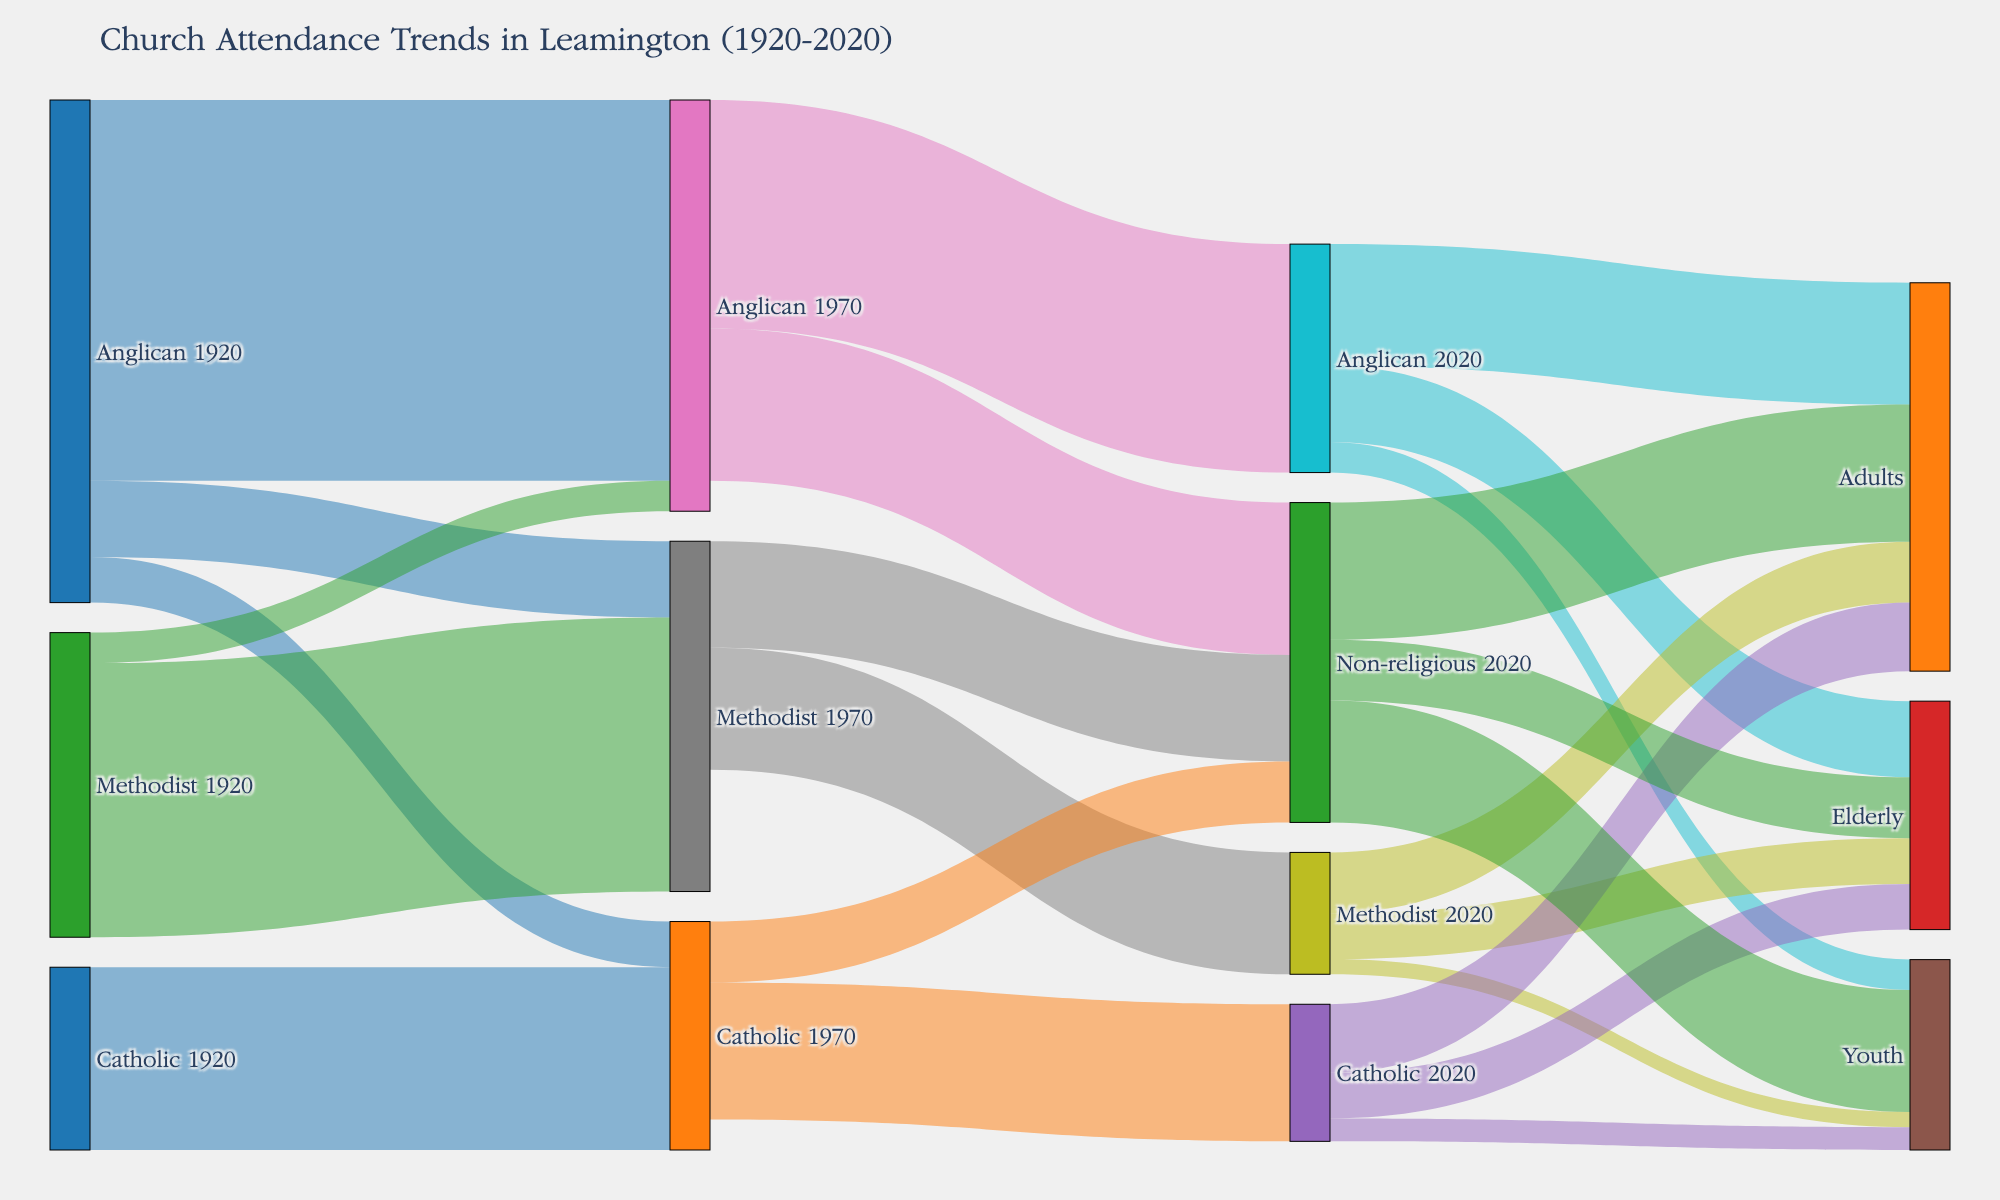How many attendees were categorized under 'Youth' for the Anglican denomination in 2020? To find the number of 'Youth' attendees for the Anglican denomination in 2020, look at the link where 'Anglican 2020' is connected to 'Youth'. The value of this link indicates the number of attendees.
Answer: 200 Which denomination in 2020 had the highest number of attendees in the 'Adults' age group? To determine which denomination had the most 'Adults' attendees in 2020, compare the link values from 'Anglican 2020', 'Methodist 2020', 'Catholic 2020', and 'Non-religious 2020' to 'Adults'. The highest value identifies the denomination.
Answer: Non-religious What is the total number of attendees who became non-religious by 2020? To find the total number of attendees who turned non-religious by 2020, sum the values of links leading to 'Non-religious 2020' from various denominations (Anglican 1970, Methodist 1970, and Catholic 1970). The sum of these values gives the answer.
Answer: 2100 How did the number of Anglican attendees change from 1920 to 1970? Did it increase or decrease and by how much? By comparing the sum of link values from 'Anglican 1920' to 'Anglican 1970', 'Methodist 1970', and 'Catholic 1970', you can find the total Anglican attendees in 1970. Then subtract the total from the initial 1920 figure to ascertain the increase or decrease.
Answer: Decreased by 3300 Which age group in 2020 had the lowest total attendance across all denominations? To find the age group with the lowest total attendance, sum the link values leading to 'Youth', 'Adults', and 'Elderly' from all denominations ('Anglican 2020', 'Methodist 2020', 'Catholic 2020', 'Non-religious 2020'). The smallest total determines the age group with the lowest attendance.
Answer: Elderly By how much did Methodist attendees decrease from 1920 to 2020? To determine the decrease in Methodist attendees, compare the sum of links from 'Methodist 1920' to 'Methodist 1970' and 'Anglican 1970' with the total Methodist attendees in 2020. Then subtract the 2020 figure from the initial 1920 one.
Answer: Decreased by 1000 Which denomination had the highest absolute drop in the number of attendees from 1970 to 2020? Evaluate the reduction in attendees for all denominations by comparing the total link values from each denomination in 1970 to their corresponding figures in 2020. The denomination with the highest decrease is identified.
Answer: Anglican 